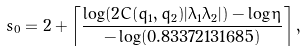<formula> <loc_0><loc_0><loc_500><loc_500>s _ { 0 } = 2 + \left \lceil \frac { \log ( 2 C ( q _ { 1 } , q _ { 2 } ) | \lambda _ { 1 } \lambda _ { 2 } | ) - \log \eta } { - \log ( 0 . 8 3 3 7 2 1 3 1 6 8 5 ) } \right \rceil ,</formula> 